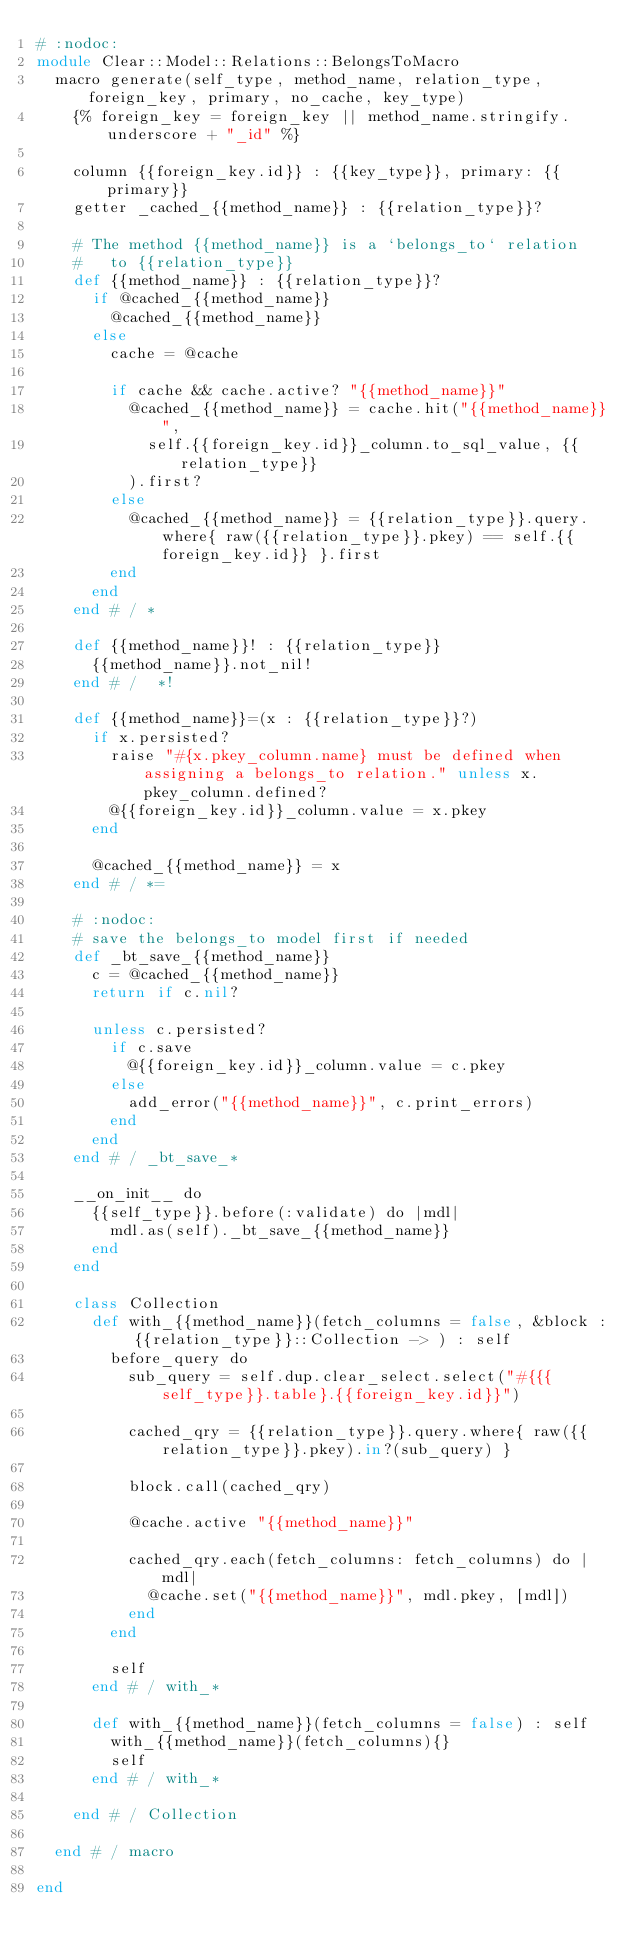Convert code to text. <code><loc_0><loc_0><loc_500><loc_500><_Crystal_># :nodoc:
module Clear::Model::Relations::BelongsToMacro
  macro generate(self_type, method_name, relation_type, foreign_key, primary, no_cache, key_type)
    {% foreign_key = foreign_key || method_name.stringify.underscore + "_id" %}

    column {{foreign_key.id}} : {{key_type}}, primary: {{primary}}
    getter _cached_{{method_name}} : {{relation_type}}?

    # The method {{method_name}} is a `belongs_to` relation
    #   to {{relation_type}}
    def {{method_name}} : {{relation_type}}?
      if @cached_{{method_name}}
        @cached_{{method_name}}
      else
        cache = @cache

        if cache && cache.active? "{{method_name}}"
          @cached_{{method_name}} = cache.hit("{{method_name}}",
            self.{{foreign_key.id}}_column.to_sql_value, {{relation_type}}
          ).first?
        else
          @cached_{{method_name}} = {{relation_type}}.query.where{ raw({{relation_type}}.pkey) == self.{{foreign_key.id}} }.first
        end
      end
    end # / *

    def {{method_name}}! : {{relation_type}}
      {{method_name}}.not_nil!
    end # /  *!

    def {{method_name}}=(x : {{relation_type}}?)
      if x.persisted?
        raise "#{x.pkey_column.name} must be defined when assigning a belongs_to relation." unless x.pkey_column.defined?
        @{{foreign_key.id}}_column.value = x.pkey
      end

      @cached_{{method_name}} = x
    end # / *=

    # :nodoc:
    # save the belongs_to model first if needed
    def _bt_save_{{method_name}}
      c = @cached_{{method_name}}
      return if c.nil?

      unless c.persisted?
        if c.save
          @{{foreign_key.id}}_column.value = c.pkey
        else
          add_error("{{method_name}}", c.print_errors)
        end
      end
    end # / _bt_save_*

    __on_init__ do
      {{self_type}}.before(:validate) do |mdl|
        mdl.as(self)._bt_save_{{method_name}}
      end
    end

    class Collection
      def with_{{method_name}}(fetch_columns = false, &block : {{relation_type}}::Collection -> ) : self
        before_query do
          sub_query = self.dup.clear_select.select("#{{{self_type}}.table}.{{foreign_key.id}}")

          cached_qry = {{relation_type}}.query.where{ raw({{relation_type}}.pkey).in?(sub_query) }

          block.call(cached_qry)

          @cache.active "{{method_name}}"

          cached_qry.each(fetch_columns: fetch_columns) do |mdl|
            @cache.set("{{method_name}}", mdl.pkey, [mdl])
          end
        end

        self
      end # / with_*

      def with_{{method_name}}(fetch_columns = false) : self
        with_{{method_name}}(fetch_columns){}
        self
      end # / with_*

    end # / Collection

  end # / macro

end</code> 